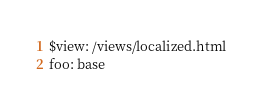Convert code to text. <code><loc_0><loc_0><loc_500><loc_500><_YAML_>$view: /views/localized.html
foo: base
</code> 